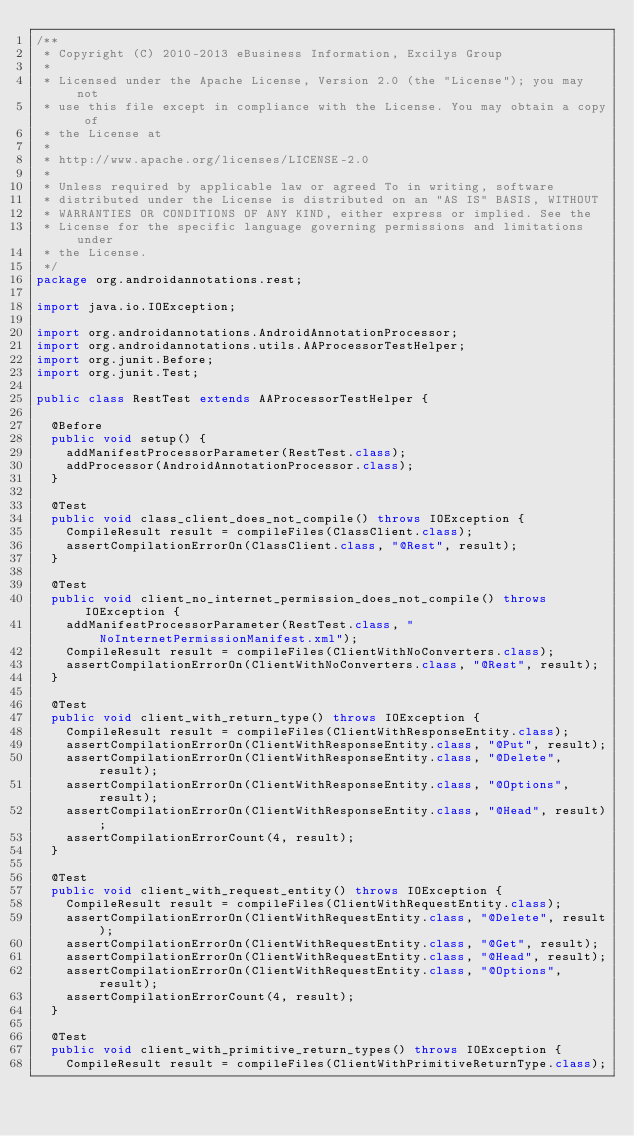<code> <loc_0><loc_0><loc_500><loc_500><_Java_>/**
 * Copyright (C) 2010-2013 eBusiness Information, Excilys Group
 *
 * Licensed under the Apache License, Version 2.0 (the "License"); you may not
 * use this file except in compliance with the License. You may obtain a copy of
 * the License at
 *
 * http://www.apache.org/licenses/LICENSE-2.0
 *
 * Unless required by applicable law or agreed To in writing, software
 * distributed under the License is distributed on an "AS IS" BASIS, WITHOUT
 * WARRANTIES OR CONDITIONS OF ANY KIND, either express or implied. See the
 * License for the specific language governing permissions and limitations under
 * the License.
 */
package org.androidannotations.rest;

import java.io.IOException;

import org.androidannotations.AndroidAnnotationProcessor;
import org.androidannotations.utils.AAProcessorTestHelper;
import org.junit.Before;
import org.junit.Test;

public class RestTest extends AAProcessorTestHelper {

	@Before
	public void setup() {
		addManifestProcessorParameter(RestTest.class);
		addProcessor(AndroidAnnotationProcessor.class);
	}

	@Test
	public void class_client_does_not_compile() throws IOException {
		CompileResult result = compileFiles(ClassClient.class);
		assertCompilationErrorOn(ClassClient.class, "@Rest", result);
	}

	@Test
	public void client_no_internet_permission_does_not_compile() throws IOException {
		addManifestProcessorParameter(RestTest.class, "NoInternetPermissionManifest.xml");
		CompileResult result = compileFiles(ClientWithNoConverters.class);
		assertCompilationErrorOn(ClientWithNoConverters.class, "@Rest", result);
	}

	@Test
	public void client_with_return_type() throws IOException {
		CompileResult result = compileFiles(ClientWithResponseEntity.class);
		assertCompilationErrorOn(ClientWithResponseEntity.class, "@Put", result);
		assertCompilationErrorOn(ClientWithResponseEntity.class, "@Delete", result);
		assertCompilationErrorOn(ClientWithResponseEntity.class, "@Options", result);
		assertCompilationErrorOn(ClientWithResponseEntity.class, "@Head", result);
		assertCompilationErrorCount(4, result);
	}

	@Test
	public void client_with_request_entity() throws IOException {
		CompileResult result = compileFiles(ClientWithRequestEntity.class);
		assertCompilationErrorOn(ClientWithRequestEntity.class, "@Delete", result);
		assertCompilationErrorOn(ClientWithRequestEntity.class, "@Get", result);
		assertCompilationErrorOn(ClientWithRequestEntity.class, "@Head", result);
		assertCompilationErrorOn(ClientWithRequestEntity.class, "@Options", result);
		assertCompilationErrorCount(4, result);
	}

	@Test
	public void client_with_primitive_return_types() throws IOException {
		CompileResult result = compileFiles(ClientWithPrimitiveReturnType.class);</code> 